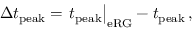<formula> <loc_0><loc_0><loc_500><loc_500>\Delta t _ { p e a k } = t _ { p e a k } \right | _ { e R G } - t _ { p e a k } \, ,</formula> 